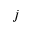Convert formula to latex. <formula><loc_0><loc_0><loc_500><loc_500>j</formula> 